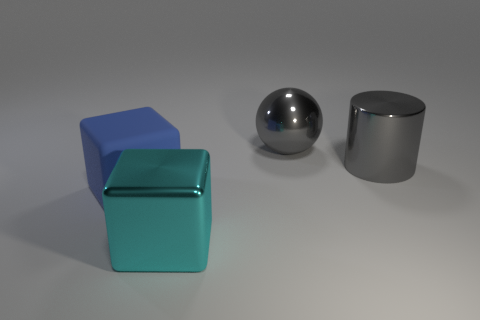How many objects are present in this scene, and can you describe them? There are four objects present in the image: a large blue cube, a smaller teal cube positioned in front of it, a reflective spherical object, and a shiny cylindrical object to the right. They are arranged on a flat surface with a plain background. 